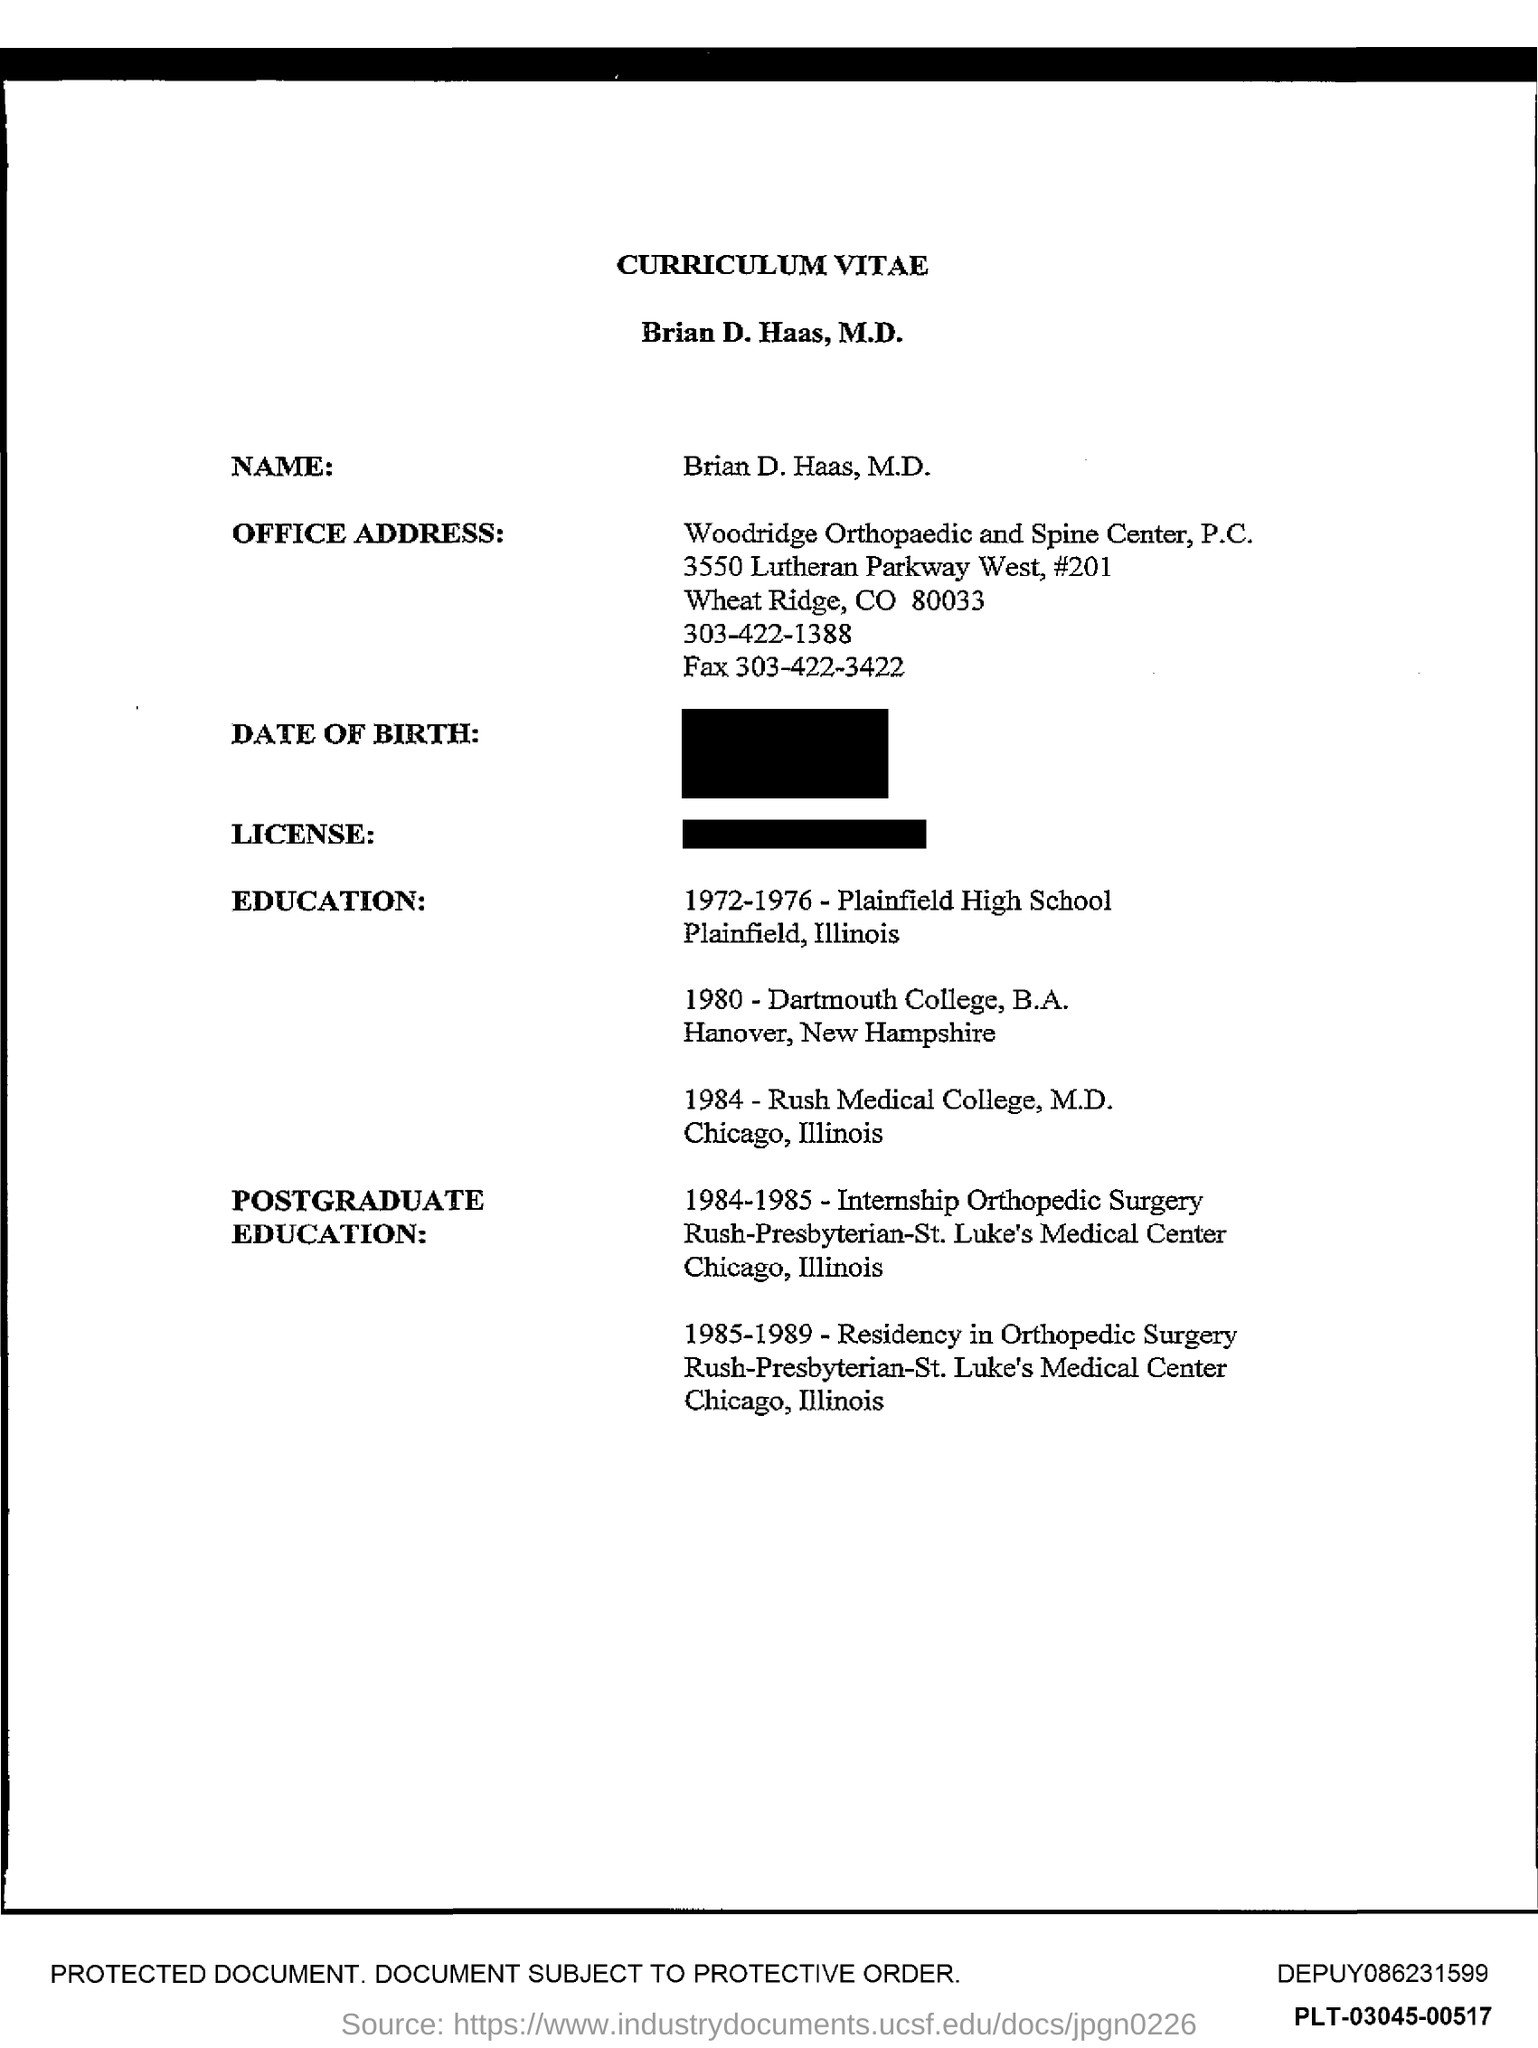Outline some significant characteristics in this image. The fax number provided in the office address is 303-422-3422. Brian D. Haas has completed a Residency in Orthopedic Surgery during the years 1985 to 1989. The location of Plainfield High School is Plainfield, Illinois. Dartmouth College is the institution where the speaker obtained a Bachelor of Arts degree. Rush Medical College is the medical college where Brian D. Haas earned his M.D. 